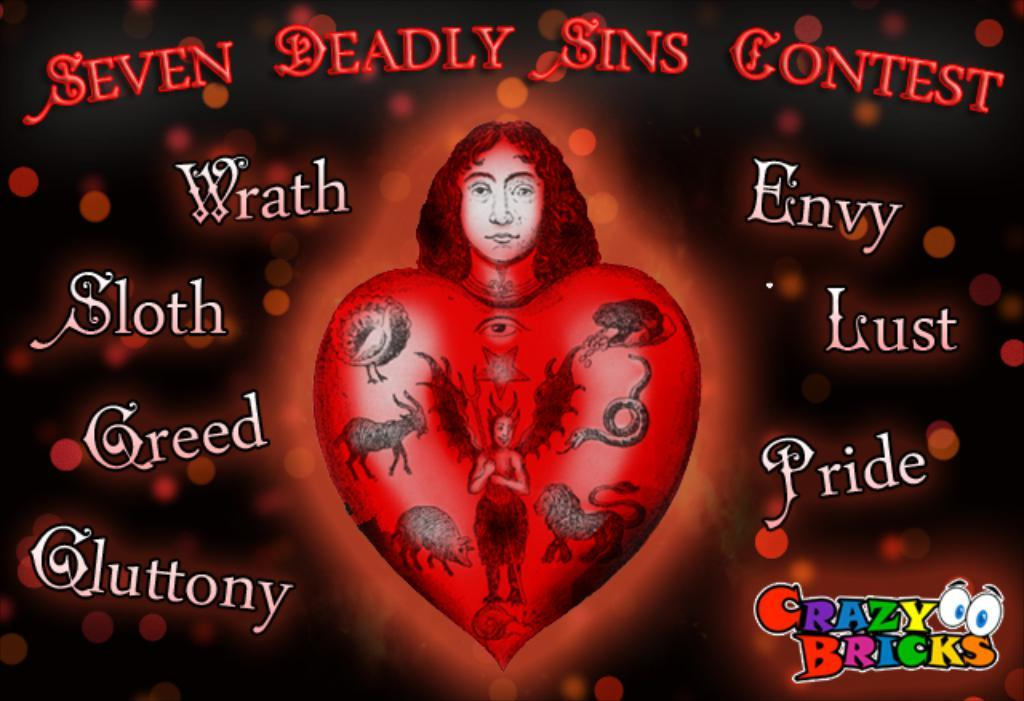What is the main object in the image? There is a poster in the image. What types of images are on the poster? The poster contains images of persons and animals. Is there any text on the poster? Yes, there is text on the poster. What direction are the animals on the poster facing? The direction the animals are facing cannot be determined from the image, as it only shows still images of the animals. 